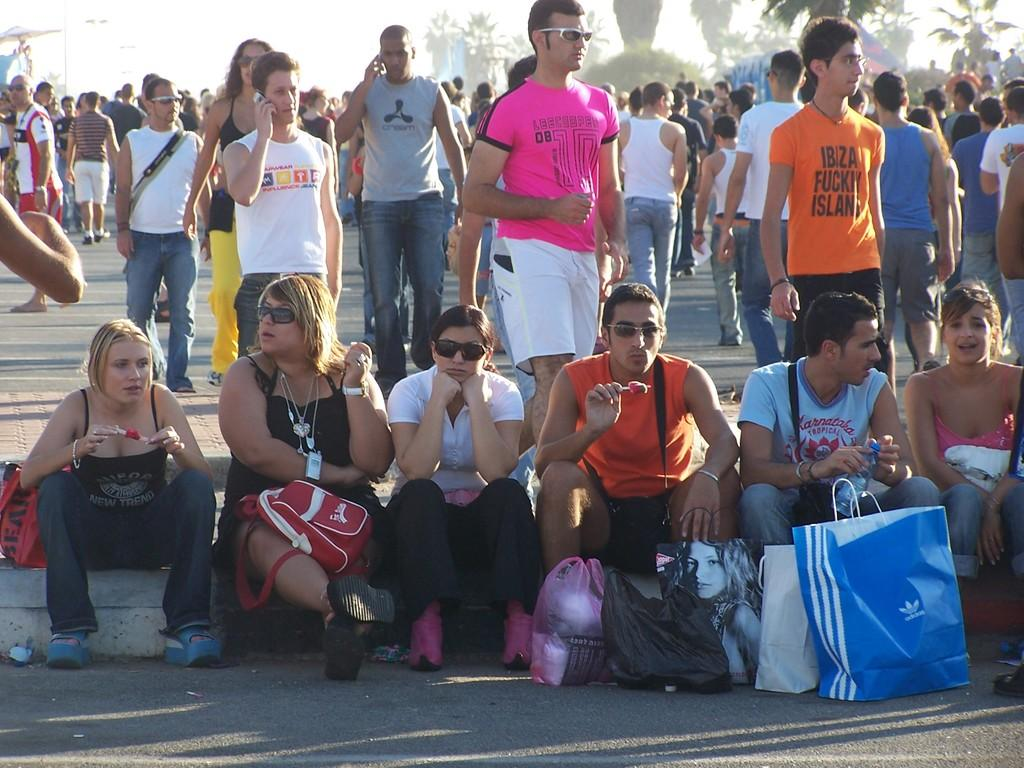<image>
Create a compact narrative representing the image presented. A large group of people sitting on a curb, one guy has an Adidas bag. 